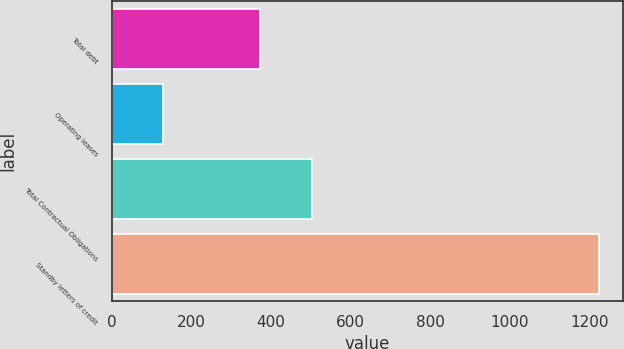<chart> <loc_0><loc_0><loc_500><loc_500><bar_chart><fcel>Total debt<fcel>Operating leases<fcel>Total Contractual Obligations<fcel>Standby letters of credit<nl><fcel>373<fcel>130<fcel>503<fcel>1224<nl></chart> 